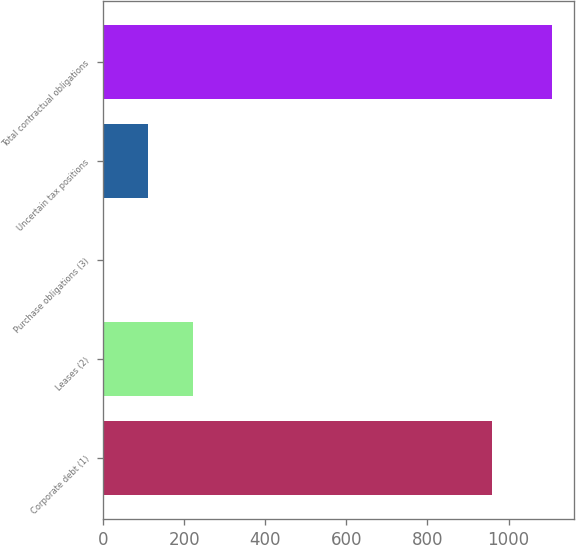Convert chart. <chart><loc_0><loc_0><loc_500><loc_500><bar_chart><fcel>Corporate debt (1)<fcel>Leases (2)<fcel>Purchase obligations (3)<fcel>Uncertain tax positions<fcel>Total contractual obligations<nl><fcel>959<fcel>222.2<fcel>1<fcel>111.6<fcel>1107<nl></chart> 